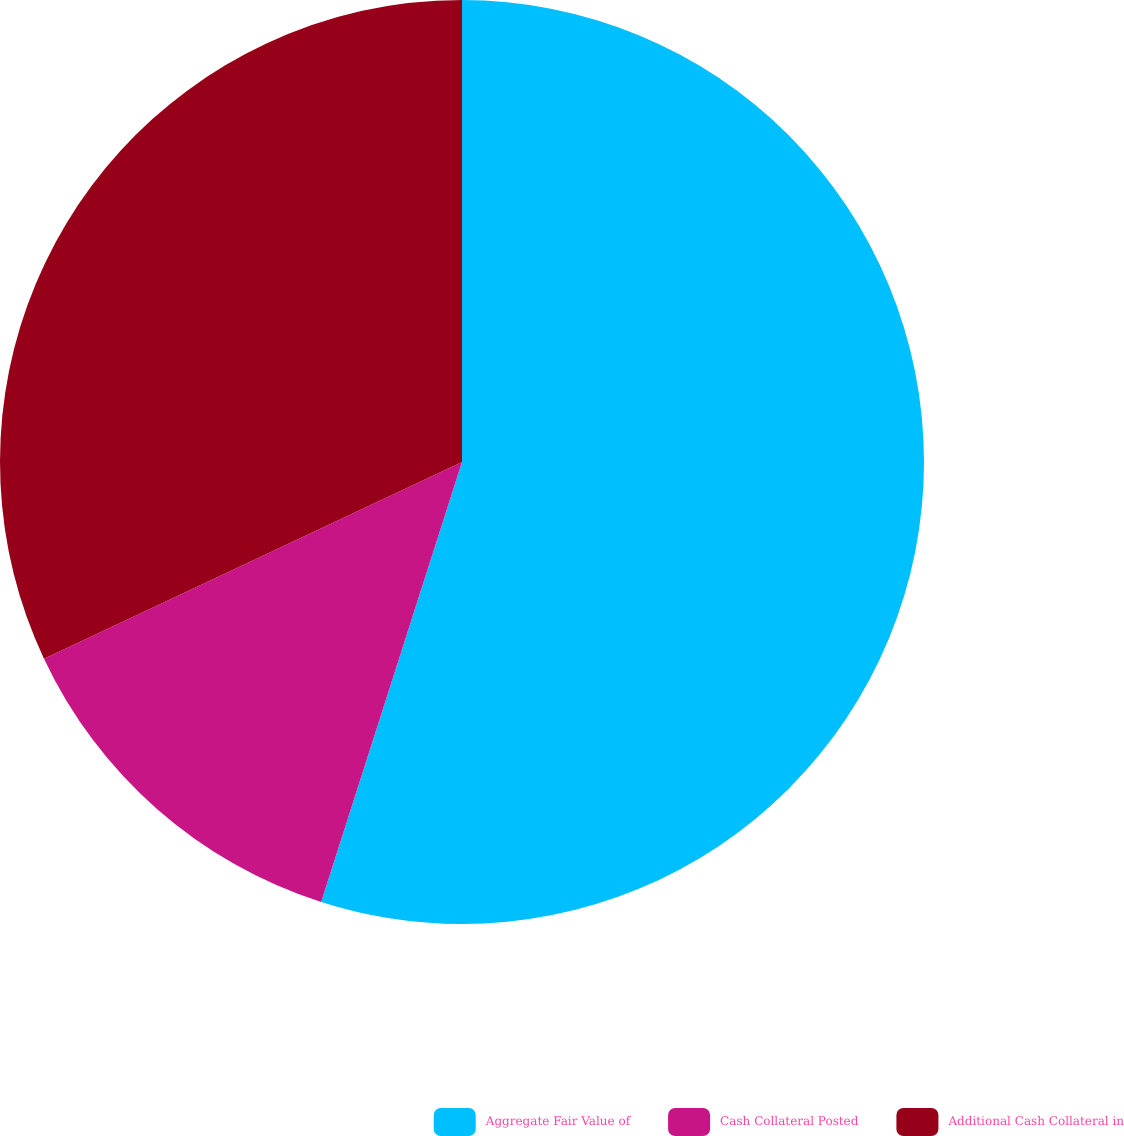Convert chart to OTSL. <chart><loc_0><loc_0><loc_500><loc_500><pie_chart><fcel>Aggregate Fair Value of<fcel>Cash Collateral Posted<fcel>Additional Cash Collateral in<nl><fcel>54.93%<fcel>13.07%<fcel>32.0%<nl></chart> 